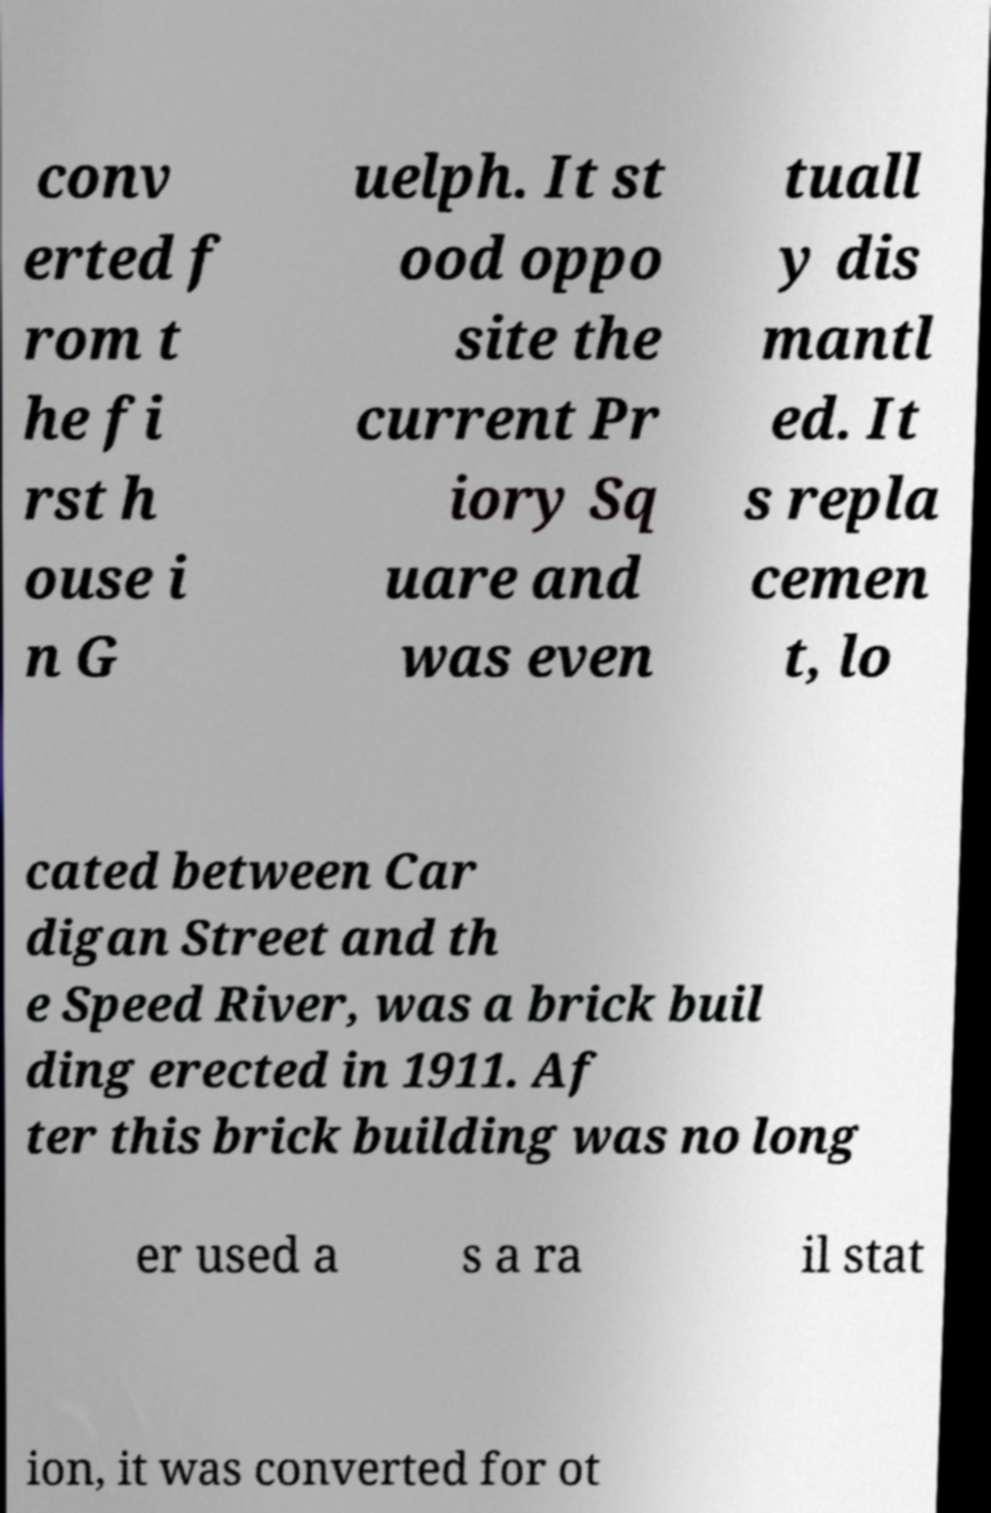Could you assist in decoding the text presented in this image and type it out clearly? conv erted f rom t he fi rst h ouse i n G uelph. It st ood oppo site the current Pr iory Sq uare and was even tuall y dis mantl ed. It s repla cemen t, lo cated between Car digan Street and th e Speed River, was a brick buil ding erected in 1911. Af ter this brick building was no long er used a s a ra il stat ion, it was converted for ot 